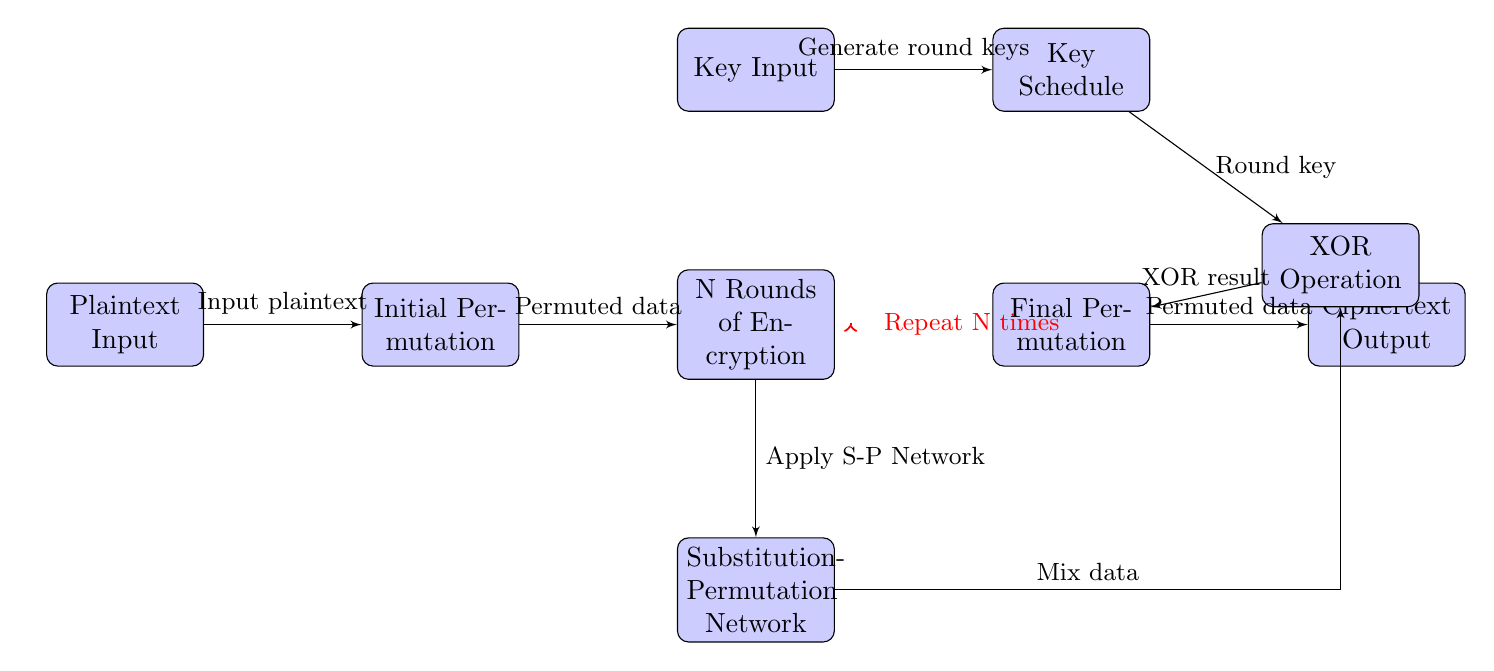What is the first step in the block cipher process? The first step in the process is the “Plaintext Input”, which indicates where the user enters the original unencrypted data.
Answer: Plaintext Input How many blocks are shown in the diagram? The diagram contains seven blocks representing the various stages in the encryption process. These include Plaintext Input, Initial Permutation, N Rounds of Encryption, Substitution-Permutation Network, Final Permutation, Ciphertext Output, Key Input, and Key Schedule.
Answer: Seven blocks What operation occurs after the Substitution-Permutation Network? After the Substitution-Permutation Network, the next operation is the XOR Operation, where the mixed data is combined with a round key.
Answer: XOR Operation What is the purpose of the Key Schedule block? The Key Schedule block is responsible for generating round keys needed at each stage of the encryption process.
Answer: Generate round keys How many times does the encryption process repeat according to the diagram? The diagram indicates that the encryption process repeats “N” times, allowing for multiple rounds of encryption for increased security.
Answer: N times What type of operation is applied to data after the Initial Permutation? After the Initial Permutation, the data undergoes N Rounds of Encryption, during which various transformations are applied to enhance security.
Answer: N Rounds of Encryption What does the Final Permutation block produce? The Final Permutation block produces the final output of the encryption process, which is the “Ciphertext Output”, representing the encrypted data.
Answer: Ciphertext Output Which component is directly fed into the XOR Operation? The XOR Operation is directly fed by the round key from the Key Schedule, as well as data from the Substitution-Permutation Network.
Answer: Round key What is the significance of the red arrow in the diagram? The red arrow signifies that the N Rounds of Encryption block is repeated multiple times, indicating the iterative nature of this process for each round of encryption.
Answer: Repeat N times 